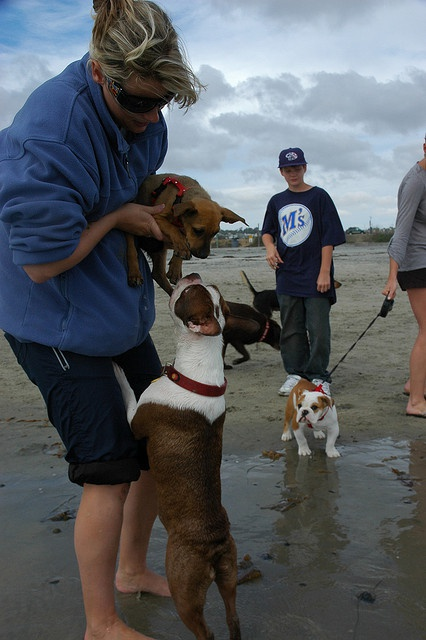Describe the objects in this image and their specific colors. I can see people in blue, black, navy, gray, and maroon tones, dog in blue, black, darkgray, maroon, and gray tones, people in blue, black, darkgray, and gray tones, dog in blue, black, maroon, and gray tones, and people in blue, gray, brown, and black tones in this image. 